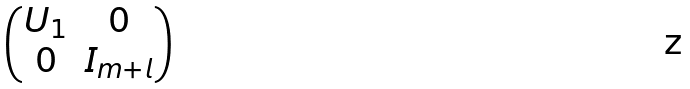Convert formula to latex. <formula><loc_0><loc_0><loc_500><loc_500>\begin{pmatrix} U _ { 1 } & 0 \\ 0 & I _ { m + l } \end{pmatrix}</formula> 